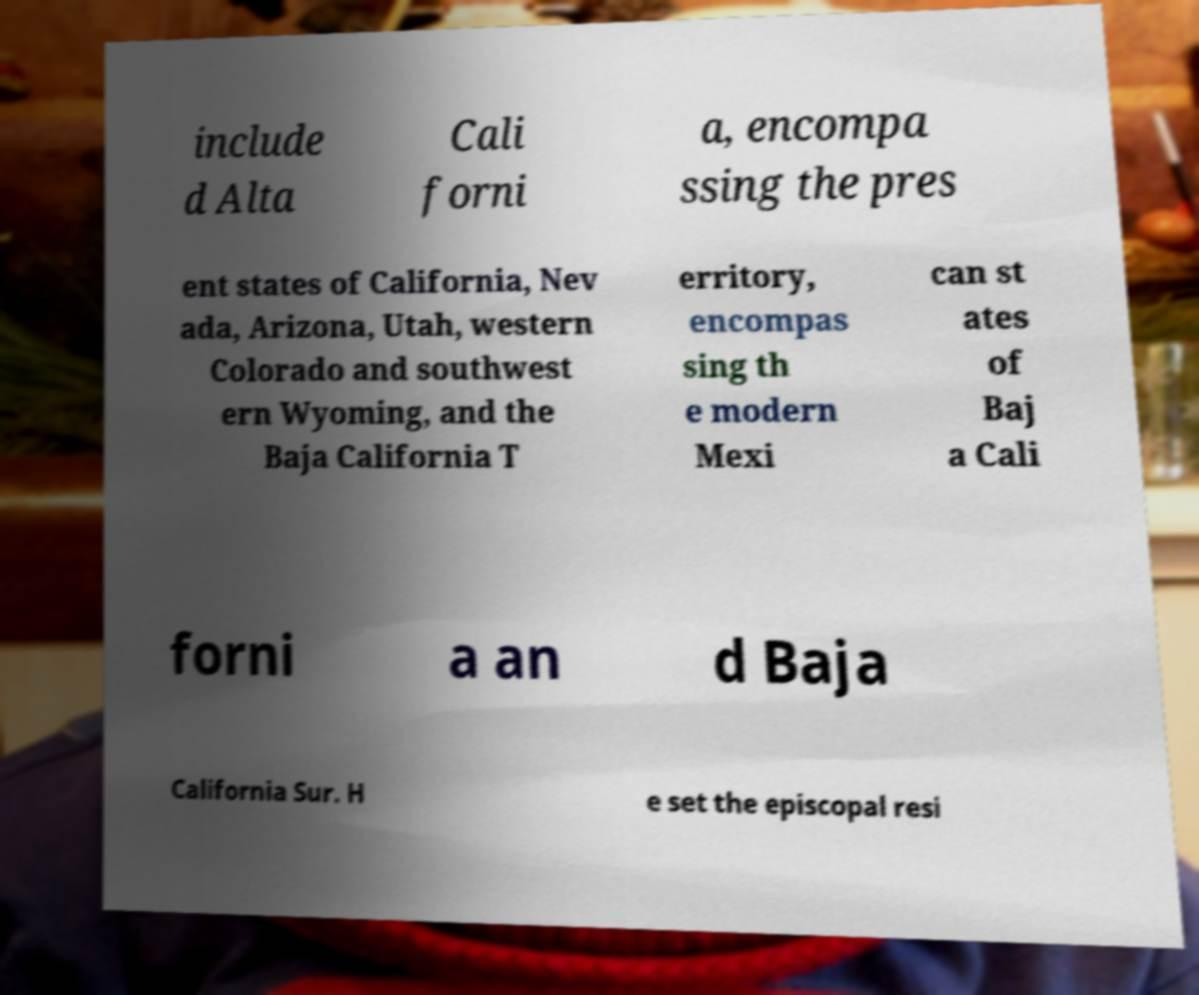Could you assist in decoding the text presented in this image and type it out clearly? include d Alta Cali forni a, encompa ssing the pres ent states of California, Nev ada, Arizona, Utah, western Colorado and southwest ern Wyoming, and the Baja California T erritory, encompas sing th e modern Mexi can st ates of Baj a Cali forni a an d Baja California Sur. H e set the episcopal resi 